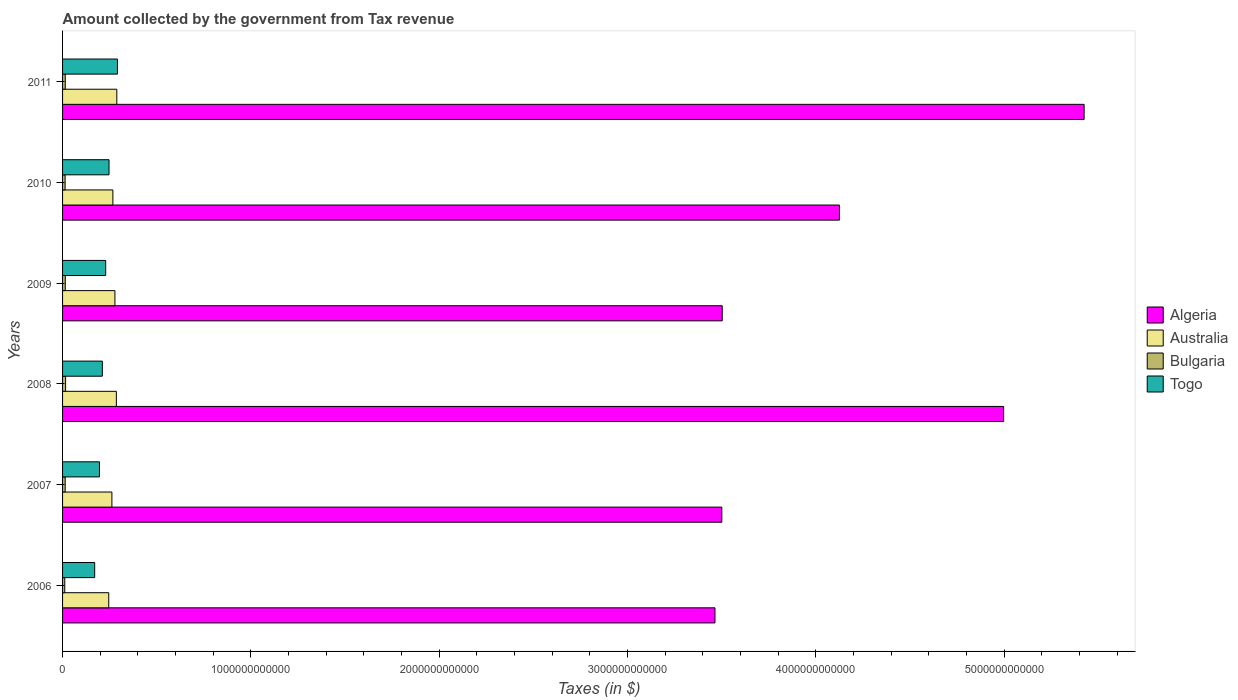How many different coloured bars are there?
Provide a short and direct response. 4. How many groups of bars are there?
Provide a succinct answer. 6. How many bars are there on the 4th tick from the top?
Keep it short and to the point. 4. How many bars are there on the 1st tick from the bottom?
Your answer should be compact. 4. What is the label of the 4th group of bars from the top?
Keep it short and to the point. 2008. What is the amount collected by the government from tax revenue in Bulgaria in 2008?
Offer a very short reply. 1.61e+1. Across all years, what is the maximum amount collected by the government from tax revenue in Togo?
Give a very brief answer. 2.91e+11. Across all years, what is the minimum amount collected by the government from tax revenue in Togo?
Give a very brief answer. 1.71e+11. In which year was the amount collected by the government from tax revenue in Togo maximum?
Provide a succinct answer. 2011. What is the total amount collected by the government from tax revenue in Togo in the graph?
Provide a succinct answer. 1.34e+12. What is the difference between the amount collected by the government from tax revenue in Australia in 2007 and that in 2010?
Your answer should be compact. -5.18e+09. What is the difference between the amount collected by the government from tax revenue in Algeria in 2010 and the amount collected by the government from tax revenue in Australia in 2007?
Make the answer very short. 3.86e+12. What is the average amount collected by the government from tax revenue in Algeria per year?
Offer a terse response. 4.17e+12. In the year 2010, what is the difference between the amount collected by the government from tax revenue in Bulgaria and amount collected by the government from tax revenue in Algeria?
Offer a terse response. -4.11e+12. In how many years, is the amount collected by the government from tax revenue in Togo greater than 1400000000000 $?
Offer a terse response. 0. What is the ratio of the amount collected by the government from tax revenue in Australia in 2008 to that in 2010?
Provide a short and direct response. 1.07. What is the difference between the highest and the second highest amount collected by the government from tax revenue in Togo?
Your response must be concise. 4.47e+1. What is the difference between the highest and the lowest amount collected by the government from tax revenue in Australia?
Offer a terse response. 4.28e+1. In how many years, is the amount collected by the government from tax revenue in Togo greater than the average amount collected by the government from tax revenue in Togo taken over all years?
Offer a terse response. 3. Is the sum of the amount collected by the government from tax revenue in Bulgaria in 2007 and 2008 greater than the maximum amount collected by the government from tax revenue in Togo across all years?
Keep it short and to the point. No. Is it the case that in every year, the sum of the amount collected by the government from tax revenue in Togo and amount collected by the government from tax revenue in Australia is greater than the sum of amount collected by the government from tax revenue in Bulgaria and amount collected by the government from tax revenue in Algeria?
Make the answer very short. No. Is it the case that in every year, the sum of the amount collected by the government from tax revenue in Algeria and amount collected by the government from tax revenue in Australia is greater than the amount collected by the government from tax revenue in Togo?
Your response must be concise. Yes. Are all the bars in the graph horizontal?
Provide a succinct answer. Yes. What is the difference between two consecutive major ticks on the X-axis?
Give a very brief answer. 1.00e+12. What is the title of the graph?
Provide a succinct answer. Amount collected by the government from Tax revenue. Does "Portugal" appear as one of the legend labels in the graph?
Your answer should be very brief. No. What is the label or title of the X-axis?
Your answer should be very brief. Taxes (in $). What is the Taxes (in $) of Algeria in 2006?
Offer a terse response. 3.46e+12. What is the Taxes (in $) in Australia in 2006?
Make the answer very short. 2.45e+11. What is the Taxes (in $) of Bulgaria in 2006?
Provide a short and direct response. 1.17e+1. What is the Taxes (in $) in Togo in 2006?
Offer a very short reply. 1.71e+11. What is the Taxes (in $) of Algeria in 2007?
Your answer should be very brief. 3.50e+12. What is the Taxes (in $) of Australia in 2007?
Offer a terse response. 2.62e+11. What is the Taxes (in $) in Bulgaria in 2007?
Your response must be concise. 1.39e+1. What is the Taxes (in $) in Togo in 2007?
Your answer should be very brief. 1.96e+11. What is the Taxes (in $) in Algeria in 2008?
Provide a succinct answer. 5.00e+12. What is the Taxes (in $) of Australia in 2008?
Your response must be concise. 2.86e+11. What is the Taxes (in $) in Bulgaria in 2008?
Your answer should be very brief. 1.61e+1. What is the Taxes (in $) of Togo in 2008?
Provide a succinct answer. 2.11e+11. What is the Taxes (in $) of Algeria in 2009?
Offer a terse response. 3.50e+12. What is the Taxes (in $) in Australia in 2009?
Give a very brief answer. 2.78e+11. What is the Taxes (in $) of Bulgaria in 2009?
Ensure brevity in your answer.  1.44e+1. What is the Taxes (in $) of Togo in 2009?
Make the answer very short. 2.29e+11. What is the Taxes (in $) of Algeria in 2010?
Make the answer very short. 4.13e+12. What is the Taxes (in $) of Australia in 2010?
Offer a very short reply. 2.67e+11. What is the Taxes (in $) in Bulgaria in 2010?
Keep it short and to the point. 1.35e+1. What is the Taxes (in $) in Togo in 2010?
Keep it short and to the point. 2.47e+11. What is the Taxes (in $) in Algeria in 2011?
Offer a very short reply. 5.42e+12. What is the Taxes (in $) in Australia in 2011?
Offer a very short reply. 2.88e+11. What is the Taxes (in $) in Bulgaria in 2011?
Make the answer very short. 1.43e+1. What is the Taxes (in $) of Togo in 2011?
Give a very brief answer. 2.91e+11. Across all years, what is the maximum Taxes (in $) of Algeria?
Your answer should be very brief. 5.42e+12. Across all years, what is the maximum Taxes (in $) of Australia?
Offer a terse response. 2.88e+11. Across all years, what is the maximum Taxes (in $) of Bulgaria?
Offer a terse response. 1.61e+1. Across all years, what is the maximum Taxes (in $) of Togo?
Your response must be concise. 2.91e+11. Across all years, what is the minimum Taxes (in $) in Algeria?
Provide a succinct answer. 3.46e+12. Across all years, what is the minimum Taxes (in $) in Australia?
Your answer should be compact. 2.45e+11. Across all years, what is the minimum Taxes (in $) of Bulgaria?
Give a very brief answer. 1.17e+1. Across all years, what is the minimum Taxes (in $) of Togo?
Keep it short and to the point. 1.71e+11. What is the total Taxes (in $) in Algeria in the graph?
Make the answer very short. 2.50e+13. What is the total Taxes (in $) in Australia in the graph?
Provide a short and direct response. 1.63e+12. What is the total Taxes (in $) of Bulgaria in the graph?
Ensure brevity in your answer.  8.39e+1. What is the total Taxes (in $) in Togo in the graph?
Your response must be concise. 1.34e+12. What is the difference between the Taxes (in $) of Algeria in 2006 and that in 2007?
Provide a succinct answer. -3.64e+1. What is the difference between the Taxes (in $) in Australia in 2006 and that in 2007?
Ensure brevity in your answer.  -1.68e+1. What is the difference between the Taxes (in $) of Bulgaria in 2006 and that in 2007?
Offer a terse response. -2.27e+09. What is the difference between the Taxes (in $) in Togo in 2006 and that in 2007?
Your response must be concise. -2.53e+1. What is the difference between the Taxes (in $) of Algeria in 2006 and that in 2008?
Your answer should be very brief. -1.53e+12. What is the difference between the Taxes (in $) in Australia in 2006 and that in 2008?
Your response must be concise. -4.04e+1. What is the difference between the Taxes (in $) of Bulgaria in 2006 and that in 2008?
Ensure brevity in your answer.  -4.47e+09. What is the difference between the Taxes (in $) in Togo in 2006 and that in 2008?
Your answer should be very brief. -4.06e+1. What is the difference between the Taxes (in $) in Algeria in 2006 and that in 2009?
Give a very brief answer. -3.86e+1. What is the difference between the Taxes (in $) of Australia in 2006 and that in 2009?
Provide a succinct answer. -3.28e+1. What is the difference between the Taxes (in $) in Bulgaria in 2006 and that in 2009?
Provide a succinct answer. -2.71e+09. What is the difference between the Taxes (in $) in Togo in 2006 and that in 2009?
Give a very brief answer. -5.85e+1. What is the difference between the Taxes (in $) in Algeria in 2006 and that in 2010?
Ensure brevity in your answer.  -6.61e+11. What is the difference between the Taxes (in $) of Australia in 2006 and that in 2010?
Provide a succinct answer. -2.19e+1. What is the difference between the Taxes (in $) in Bulgaria in 2006 and that in 2010?
Provide a short and direct response. -1.85e+09. What is the difference between the Taxes (in $) of Togo in 2006 and that in 2010?
Ensure brevity in your answer.  -7.62e+1. What is the difference between the Taxes (in $) of Algeria in 2006 and that in 2011?
Your answer should be very brief. -1.96e+12. What is the difference between the Taxes (in $) of Australia in 2006 and that in 2011?
Provide a short and direct response. -4.28e+1. What is the difference between the Taxes (in $) of Bulgaria in 2006 and that in 2011?
Make the answer very short. -2.70e+09. What is the difference between the Taxes (in $) of Togo in 2006 and that in 2011?
Make the answer very short. -1.21e+11. What is the difference between the Taxes (in $) in Algeria in 2007 and that in 2008?
Ensure brevity in your answer.  -1.50e+12. What is the difference between the Taxes (in $) in Australia in 2007 and that in 2008?
Give a very brief answer. -2.37e+1. What is the difference between the Taxes (in $) of Bulgaria in 2007 and that in 2008?
Give a very brief answer. -2.20e+09. What is the difference between the Taxes (in $) in Togo in 2007 and that in 2008?
Keep it short and to the point. -1.53e+1. What is the difference between the Taxes (in $) in Algeria in 2007 and that in 2009?
Offer a very short reply. -2.17e+09. What is the difference between the Taxes (in $) in Australia in 2007 and that in 2009?
Provide a succinct answer. -1.60e+1. What is the difference between the Taxes (in $) of Bulgaria in 2007 and that in 2009?
Your answer should be compact. -4.37e+08. What is the difference between the Taxes (in $) in Togo in 2007 and that in 2009?
Offer a terse response. -3.32e+1. What is the difference between the Taxes (in $) in Algeria in 2007 and that in 2010?
Your answer should be compact. -6.25e+11. What is the difference between the Taxes (in $) in Australia in 2007 and that in 2010?
Offer a very short reply. -5.18e+09. What is the difference between the Taxes (in $) in Bulgaria in 2007 and that in 2010?
Give a very brief answer. 4.21e+08. What is the difference between the Taxes (in $) of Togo in 2007 and that in 2010?
Make the answer very short. -5.09e+1. What is the difference between the Taxes (in $) of Algeria in 2007 and that in 2011?
Make the answer very short. -1.92e+12. What is the difference between the Taxes (in $) of Australia in 2007 and that in 2011?
Provide a succinct answer. -2.61e+1. What is the difference between the Taxes (in $) of Bulgaria in 2007 and that in 2011?
Your response must be concise. -4.28e+08. What is the difference between the Taxes (in $) in Togo in 2007 and that in 2011?
Provide a succinct answer. -9.56e+1. What is the difference between the Taxes (in $) of Algeria in 2008 and that in 2009?
Provide a succinct answer. 1.49e+12. What is the difference between the Taxes (in $) in Australia in 2008 and that in 2009?
Keep it short and to the point. 7.66e+09. What is the difference between the Taxes (in $) of Bulgaria in 2008 and that in 2009?
Keep it short and to the point. 1.77e+09. What is the difference between the Taxes (in $) of Togo in 2008 and that in 2009?
Give a very brief answer. -1.79e+1. What is the difference between the Taxes (in $) of Algeria in 2008 and that in 2010?
Offer a terse response. 8.72e+11. What is the difference between the Taxes (in $) in Australia in 2008 and that in 2010?
Offer a very short reply. 1.85e+1. What is the difference between the Taxes (in $) of Bulgaria in 2008 and that in 2010?
Provide a short and direct response. 2.62e+09. What is the difference between the Taxes (in $) in Togo in 2008 and that in 2010?
Give a very brief answer. -3.56e+1. What is the difference between the Taxes (in $) in Algeria in 2008 and that in 2011?
Your answer should be compact. -4.27e+11. What is the difference between the Taxes (in $) of Australia in 2008 and that in 2011?
Offer a very short reply. -2.41e+09. What is the difference between the Taxes (in $) in Bulgaria in 2008 and that in 2011?
Your answer should be very brief. 1.78e+09. What is the difference between the Taxes (in $) of Togo in 2008 and that in 2011?
Ensure brevity in your answer.  -8.02e+1. What is the difference between the Taxes (in $) in Algeria in 2009 and that in 2010?
Provide a succinct answer. -6.22e+11. What is the difference between the Taxes (in $) of Australia in 2009 and that in 2010?
Offer a terse response. 1.08e+1. What is the difference between the Taxes (in $) in Bulgaria in 2009 and that in 2010?
Keep it short and to the point. 8.58e+08. What is the difference between the Taxes (in $) in Togo in 2009 and that in 2010?
Your answer should be compact. -1.77e+1. What is the difference between the Taxes (in $) in Algeria in 2009 and that in 2011?
Offer a very short reply. -1.92e+12. What is the difference between the Taxes (in $) in Australia in 2009 and that in 2011?
Offer a terse response. -1.01e+1. What is the difference between the Taxes (in $) of Bulgaria in 2009 and that in 2011?
Keep it short and to the point. 9.09e+06. What is the difference between the Taxes (in $) in Togo in 2009 and that in 2011?
Your answer should be very brief. -6.24e+1. What is the difference between the Taxes (in $) in Algeria in 2010 and that in 2011?
Your answer should be very brief. -1.30e+12. What is the difference between the Taxes (in $) of Australia in 2010 and that in 2011?
Provide a short and direct response. -2.09e+1. What is the difference between the Taxes (in $) of Bulgaria in 2010 and that in 2011?
Provide a succinct answer. -8.49e+08. What is the difference between the Taxes (in $) of Togo in 2010 and that in 2011?
Your answer should be compact. -4.47e+1. What is the difference between the Taxes (in $) in Algeria in 2006 and the Taxes (in $) in Australia in 2007?
Give a very brief answer. 3.20e+12. What is the difference between the Taxes (in $) of Algeria in 2006 and the Taxes (in $) of Bulgaria in 2007?
Give a very brief answer. 3.45e+12. What is the difference between the Taxes (in $) of Algeria in 2006 and the Taxes (in $) of Togo in 2007?
Make the answer very short. 3.27e+12. What is the difference between the Taxes (in $) of Australia in 2006 and the Taxes (in $) of Bulgaria in 2007?
Provide a short and direct response. 2.31e+11. What is the difference between the Taxes (in $) in Australia in 2006 and the Taxes (in $) in Togo in 2007?
Provide a short and direct response. 4.94e+1. What is the difference between the Taxes (in $) in Bulgaria in 2006 and the Taxes (in $) in Togo in 2007?
Your answer should be compact. -1.84e+11. What is the difference between the Taxes (in $) of Algeria in 2006 and the Taxes (in $) of Australia in 2008?
Provide a succinct answer. 3.18e+12. What is the difference between the Taxes (in $) in Algeria in 2006 and the Taxes (in $) in Bulgaria in 2008?
Provide a succinct answer. 3.45e+12. What is the difference between the Taxes (in $) of Algeria in 2006 and the Taxes (in $) of Togo in 2008?
Your response must be concise. 3.25e+12. What is the difference between the Taxes (in $) of Australia in 2006 and the Taxes (in $) of Bulgaria in 2008?
Make the answer very short. 2.29e+11. What is the difference between the Taxes (in $) of Australia in 2006 and the Taxes (in $) of Togo in 2008?
Your answer should be very brief. 3.40e+1. What is the difference between the Taxes (in $) of Bulgaria in 2006 and the Taxes (in $) of Togo in 2008?
Provide a succinct answer. -2.00e+11. What is the difference between the Taxes (in $) in Algeria in 2006 and the Taxes (in $) in Australia in 2009?
Make the answer very short. 3.19e+12. What is the difference between the Taxes (in $) of Algeria in 2006 and the Taxes (in $) of Bulgaria in 2009?
Your answer should be very brief. 3.45e+12. What is the difference between the Taxes (in $) in Algeria in 2006 and the Taxes (in $) in Togo in 2009?
Provide a succinct answer. 3.24e+12. What is the difference between the Taxes (in $) of Australia in 2006 and the Taxes (in $) of Bulgaria in 2009?
Offer a very short reply. 2.31e+11. What is the difference between the Taxes (in $) of Australia in 2006 and the Taxes (in $) of Togo in 2009?
Your answer should be compact. 1.61e+1. What is the difference between the Taxes (in $) of Bulgaria in 2006 and the Taxes (in $) of Togo in 2009?
Make the answer very short. -2.17e+11. What is the difference between the Taxes (in $) of Algeria in 2006 and the Taxes (in $) of Australia in 2010?
Your answer should be very brief. 3.20e+12. What is the difference between the Taxes (in $) in Algeria in 2006 and the Taxes (in $) in Bulgaria in 2010?
Offer a terse response. 3.45e+12. What is the difference between the Taxes (in $) in Algeria in 2006 and the Taxes (in $) in Togo in 2010?
Your answer should be very brief. 3.22e+12. What is the difference between the Taxes (in $) in Australia in 2006 and the Taxes (in $) in Bulgaria in 2010?
Give a very brief answer. 2.32e+11. What is the difference between the Taxes (in $) of Australia in 2006 and the Taxes (in $) of Togo in 2010?
Your answer should be very brief. -1.56e+09. What is the difference between the Taxes (in $) in Bulgaria in 2006 and the Taxes (in $) in Togo in 2010?
Provide a succinct answer. -2.35e+11. What is the difference between the Taxes (in $) of Algeria in 2006 and the Taxes (in $) of Australia in 2011?
Keep it short and to the point. 3.18e+12. What is the difference between the Taxes (in $) in Algeria in 2006 and the Taxes (in $) in Bulgaria in 2011?
Your answer should be very brief. 3.45e+12. What is the difference between the Taxes (in $) of Algeria in 2006 and the Taxes (in $) of Togo in 2011?
Give a very brief answer. 3.17e+12. What is the difference between the Taxes (in $) in Australia in 2006 and the Taxes (in $) in Bulgaria in 2011?
Your answer should be very brief. 2.31e+11. What is the difference between the Taxes (in $) in Australia in 2006 and the Taxes (in $) in Togo in 2011?
Your response must be concise. -4.62e+1. What is the difference between the Taxes (in $) in Bulgaria in 2006 and the Taxes (in $) in Togo in 2011?
Ensure brevity in your answer.  -2.80e+11. What is the difference between the Taxes (in $) of Algeria in 2007 and the Taxes (in $) of Australia in 2008?
Your answer should be very brief. 3.22e+12. What is the difference between the Taxes (in $) of Algeria in 2007 and the Taxes (in $) of Bulgaria in 2008?
Ensure brevity in your answer.  3.48e+12. What is the difference between the Taxes (in $) in Algeria in 2007 and the Taxes (in $) in Togo in 2008?
Ensure brevity in your answer.  3.29e+12. What is the difference between the Taxes (in $) of Australia in 2007 and the Taxes (in $) of Bulgaria in 2008?
Your response must be concise. 2.46e+11. What is the difference between the Taxes (in $) of Australia in 2007 and the Taxes (in $) of Togo in 2008?
Offer a very short reply. 5.08e+1. What is the difference between the Taxes (in $) of Bulgaria in 2007 and the Taxes (in $) of Togo in 2008?
Ensure brevity in your answer.  -1.97e+11. What is the difference between the Taxes (in $) in Algeria in 2007 and the Taxes (in $) in Australia in 2009?
Provide a short and direct response. 3.22e+12. What is the difference between the Taxes (in $) in Algeria in 2007 and the Taxes (in $) in Bulgaria in 2009?
Offer a very short reply. 3.49e+12. What is the difference between the Taxes (in $) of Algeria in 2007 and the Taxes (in $) of Togo in 2009?
Provide a short and direct response. 3.27e+12. What is the difference between the Taxes (in $) in Australia in 2007 and the Taxes (in $) in Bulgaria in 2009?
Ensure brevity in your answer.  2.48e+11. What is the difference between the Taxes (in $) of Australia in 2007 and the Taxes (in $) of Togo in 2009?
Your answer should be compact. 3.29e+1. What is the difference between the Taxes (in $) in Bulgaria in 2007 and the Taxes (in $) in Togo in 2009?
Your answer should be compact. -2.15e+11. What is the difference between the Taxes (in $) of Algeria in 2007 and the Taxes (in $) of Australia in 2010?
Offer a very short reply. 3.23e+12. What is the difference between the Taxes (in $) of Algeria in 2007 and the Taxes (in $) of Bulgaria in 2010?
Ensure brevity in your answer.  3.49e+12. What is the difference between the Taxes (in $) in Algeria in 2007 and the Taxes (in $) in Togo in 2010?
Offer a terse response. 3.25e+12. What is the difference between the Taxes (in $) of Australia in 2007 and the Taxes (in $) of Bulgaria in 2010?
Make the answer very short. 2.48e+11. What is the difference between the Taxes (in $) of Australia in 2007 and the Taxes (in $) of Togo in 2010?
Your answer should be compact. 1.52e+1. What is the difference between the Taxes (in $) of Bulgaria in 2007 and the Taxes (in $) of Togo in 2010?
Offer a very short reply. -2.33e+11. What is the difference between the Taxes (in $) of Algeria in 2007 and the Taxes (in $) of Australia in 2011?
Give a very brief answer. 3.21e+12. What is the difference between the Taxes (in $) in Algeria in 2007 and the Taxes (in $) in Bulgaria in 2011?
Keep it short and to the point. 3.49e+12. What is the difference between the Taxes (in $) of Algeria in 2007 and the Taxes (in $) of Togo in 2011?
Your answer should be compact. 3.21e+12. What is the difference between the Taxes (in $) of Australia in 2007 and the Taxes (in $) of Bulgaria in 2011?
Your answer should be compact. 2.48e+11. What is the difference between the Taxes (in $) of Australia in 2007 and the Taxes (in $) of Togo in 2011?
Offer a terse response. -2.95e+1. What is the difference between the Taxes (in $) of Bulgaria in 2007 and the Taxes (in $) of Togo in 2011?
Provide a short and direct response. -2.78e+11. What is the difference between the Taxes (in $) of Algeria in 2008 and the Taxes (in $) of Australia in 2009?
Ensure brevity in your answer.  4.72e+12. What is the difference between the Taxes (in $) in Algeria in 2008 and the Taxes (in $) in Bulgaria in 2009?
Your answer should be very brief. 4.98e+12. What is the difference between the Taxes (in $) in Algeria in 2008 and the Taxes (in $) in Togo in 2009?
Your answer should be compact. 4.77e+12. What is the difference between the Taxes (in $) in Australia in 2008 and the Taxes (in $) in Bulgaria in 2009?
Your response must be concise. 2.71e+11. What is the difference between the Taxes (in $) in Australia in 2008 and the Taxes (in $) in Togo in 2009?
Make the answer very short. 5.66e+1. What is the difference between the Taxes (in $) of Bulgaria in 2008 and the Taxes (in $) of Togo in 2009?
Keep it short and to the point. -2.13e+11. What is the difference between the Taxes (in $) in Algeria in 2008 and the Taxes (in $) in Australia in 2010?
Ensure brevity in your answer.  4.73e+12. What is the difference between the Taxes (in $) in Algeria in 2008 and the Taxes (in $) in Bulgaria in 2010?
Offer a terse response. 4.98e+12. What is the difference between the Taxes (in $) in Algeria in 2008 and the Taxes (in $) in Togo in 2010?
Your answer should be very brief. 4.75e+12. What is the difference between the Taxes (in $) of Australia in 2008 and the Taxes (in $) of Bulgaria in 2010?
Offer a terse response. 2.72e+11. What is the difference between the Taxes (in $) of Australia in 2008 and the Taxes (in $) of Togo in 2010?
Offer a very short reply. 3.89e+1. What is the difference between the Taxes (in $) in Bulgaria in 2008 and the Taxes (in $) in Togo in 2010?
Make the answer very short. -2.31e+11. What is the difference between the Taxes (in $) in Algeria in 2008 and the Taxes (in $) in Australia in 2011?
Your answer should be very brief. 4.71e+12. What is the difference between the Taxes (in $) of Algeria in 2008 and the Taxes (in $) of Bulgaria in 2011?
Give a very brief answer. 4.98e+12. What is the difference between the Taxes (in $) of Algeria in 2008 and the Taxes (in $) of Togo in 2011?
Ensure brevity in your answer.  4.71e+12. What is the difference between the Taxes (in $) in Australia in 2008 and the Taxes (in $) in Bulgaria in 2011?
Your answer should be very brief. 2.71e+11. What is the difference between the Taxes (in $) in Australia in 2008 and the Taxes (in $) in Togo in 2011?
Make the answer very short. -5.78e+09. What is the difference between the Taxes (in $) of Bulgaria in 2008 and the Taxes (in $) of Togo in 2011?
Your answer should be compact. -2.75e+11. What is the difference between the Taxes (in $) in Algeria in 2009 and the Taxes (in $) in Australia in 2010?
Offer a terse response. 3.24e+12. What is the difference between the Taxes (in $) in Algeria in 2009 and the Taxes (in $) in Bulgaria in 2010?
Offer a terse response. 3.49e+12. What is the difference between the Taxes (in $) of Algeria in 2009 and the Taxes (in $) of Togo in 2010?
Your answer should be very brief. 3.26e+12. What is the difference between the Taxes (in $) of Australia in 2009 and the Taxes (in $) of Bulgaria in 2010?
Your answer should be very brief. 2.64e+11. What is the difference between the Taxes (in $) of Australia in 2009 and the Taxes (in $) of Togo in 2010?
Give a very brief answer. 3.12e+1. What is the difference between the Taxes (in $) of Bulgaria in 2009 and the Taxes (in $) of Togo in 2010?
Make the answer very short. -2.32e+11. What is the difference between the Taxes (in $) in Algeria in 2009 and the Taxes (in $) in Australia in 2011?
Offer a very short reply. 3.21e+12. What is the difference between the Taxes (in $) of Algeria in 2009 and the Taxes (in $) of Bulgaria in 2011?
Your answer should be compact. 3.49e+12. What is the difference between the Taxes (in $) in Algeria in 2009 and the Taxes (in $) in Togo in 2011?
Provide a short and direct response. 3.21e+12. What is the difference between the Taxes (in $) in Australia in 2009 and the Taxes (in $) in Bulgaria in 2011?
Your answer should be compact. 2.64e+11. What is the difference between the Taxes (in $) in Australia in 2009 and the Taxes (in $) in Togo in 2011?
Ensure brevity in your answer.  -1.34e+1. What is the difference between the Taxes (in $) in Bulgaria in 2009 and the Taxes (in $) in Togo in 2011?
Your answer should be very brief. -2.77e+11. What is the difference between the Taxes (in $) of Algeria in 2010 and the Taxes (in $) of Australia in 2011?
Keep it short and to the point. 3.84e+12. What is the difference between the Taxes (in $) of Algeria in 2010 and the Taxes (in $) of Bulgaria in 2011?
Keep it short and to the point. 4.11e+12. What is the difference between the Taxes (in $) in Algeria in 2010 and the Taxes (in $) in Togo in 2011?
Give a very brief answer. 3.83e+12. What is the difference between the Taxes (in $) of Australia in 2010 and the Taxes (in $) of Bulgaria in 2011?
Make the answer very short. 2.53e+11. What is the difference between the Taxes (in $) in Australia in 2010 and the Taxes (in $) in Togo in 2011?
Your answer should be very brief. -2.43e+1. What is the difference between the Taxes (in $) in Bulgaria in 2010 and the Taxes (in $) in Togo in 2011?
Provide a short and direct response. -2.78e+11. What is the average Taxes (in $) in Algeria per year?
Ensure brevity in your answer.  4.17e+12. What is the average Taxes (in $) of Australia per year?
Offer a terse response. 2.71e+11. What is the average Taxes (in $) of Bulgaria per year?
Provide a short and direct response. 1.40e+1. What is the average Taxes (in $) in Togo per year?
Ensure brevity in your answer.  2.24e+11. In the year 2006, what is the difference between the Taxes (in $) of Algeria and Taxes (in $) of Australia?
Keep it short and to the point. 3.22e+12. In the year 2006, what is the difference between the Taxes (in $) in Algeria and Taxes (in $) in Bulgaria?
Ensure brevity in your answer.  3.45e+12. In the year 2006, what is the difference between the Taxes (in $) in Algeria and Taxes (in $) in Togo?
Make the answer very short. 3.29e+12. In the year 2006, what is the difference between the Taxes (in $) of Australia and Taxes (in $) of Bulgaria?
Offer a terse response. 2.34e+11. In the year 2006, what is the difference between the Taxes (in $) of Australia and Taxes (in $) of Togo?
Provide a short and direct response. 7.46e+1. In the year 2006, what is the difference between the Taxes (in $) of Bulgaria and Taxes (in $) of Togo?
Give a very brief answer. -1.59e+11. In the year 2007, what is the difference between the Taxes (in $) of Algeria and Taxes (in $) of Australia?
Make the answer very short. 3.24e+12. In the year 2007, what is the difference between the Taxes (in $) in Algeria and Taxes (in $) in Bulgaria?
Provide a succinct answer. 3.49e+12. In the year 2007, what is the difference between the Taxes (in $) in Algeria and Taxes (in $) in Togo?
Ensure brevity in your answer.  3.31e+12. In the year 2007, what is the difference between the Taxes (in $) of Australia and Taxes (in $) of Bulgaria?
Provide a short and direct response. 2.48e+11. In the year 2007, what is the difference between the Taxes (in $) of Australia and Taxes (in $) of Togo?
Provide a short and direct response. 6.61e+1. In the year 2007, what is the difference between the Taxes (in $) in Bulgaria and Taxes (in $) in Togo?
Your answer should be compact. -1.82e+11. In the year 2008, what is the difference between the Taxes (in $) of Algeria and Taxes (in $) of Australia?
Your answer should be compact. 4.71e+12. In the year 2008, what is the difference between the Taxes (in $) in Algeria and Taxes (in $) in Bulgaria?
Your answer should be very brief. 4.98e+12. In the year 2008, what is the difference between the Taxes (in $) of Algeria and Taxes (in $) of Togo?
Ensure brevity in your answer.  4.79e+12. In the year 2008, what is the difference between the Taxes (in $) of Australia and Taxes (in $) of Bulgaria?
Ensure brevity in your answer.  2.70e+11. In the year 2008, what is the difference between the Taxes (in $) of Australia and Taxes (in $) of Togo?
Provide a succinct answer. 7.45e+1. In the year 2008, what is the difference between the Taxes (in $) in Bulgaria and Taxes (in $) in Togo?
Your answer should be compact. -1.95e+11. In the year 2009, what is the difference between the Taxes (in $) in Algeria and Taxes (in $) in Australia?
Ensure brevity in your answer.  3.23e+12. In the year 2009, what is the difference between the Taxes (in $) of Algeria and Taxes (in $) of Bulgaria?
Ensure brevity in your answer.  3.49e+12. In the year 2009, what is the difference between the Taxes (in $) of Algeria and Taxes (in $) of Togo?
Make the answer very short. 3.27e+12. In the year 2009, what is the difference between the Taxes (in $) in Australia and Taxes (in $) in Bulgaria?
Keep it short and to the point. 2.64e+11. In the year 2009, what is the difference between the Taxes (in $) in Australia and Taxes (in $) in Togo?
Give a very brief answer. 4.89e+1. In the year 2009, what is the difference between the Taxes (in $) of Bulgaria and Taxes (in $) of Togo?
Make the answer very short. -2.15e+11. In the year 2010, what is the difference between the Taxes (in $) in Algeria and Taxes (in $) in Australia?
Your response must be concise. 3.86e+12. In the year 2010, what is the difference between the Taxes (in $) in Algeria and Taxes (in $) in Bulgaria?
Give a very brief answer. 4.11e+12. In the year 2010, what is the difference between the Taxes (in $) in Algeria and Taxes (in $) in Togo?
Your response must be concise. 3.88e+12. In the year 2010, what is the difference between the Taxes (in $) in Australia and Taxes (in $) in Bulgaria?
Your response must be concise. 2.54e+11. In the year 2010, what is the difference between the Taxes (in $) in Australia and Taxes (in $) in Togo?
Offer a very short reply. 2.04e+1. In the year 2010, what is the difference between the Taxes (in $) in Bulgaria and Taxes (in $) in Togo?
Offer a terse response. -2.33e+11. In the year 2011, what is the difference between the Taxes (in $) of Algeria and Taxes (in $) of Australia?
Provide a short and direct response. 5.14e+12. In the year 2011, what is the difference between the Taxes (in $) in Algeria and Taxes (in $) in Bulgaria?
Offer a very short reply. 5.41e+12. In the year 2011, what is the difference between the Taxes (in $) of Algeria and Taxes (in $) of Togo?
Your response must be concise. 5.13e+12. In the year 2011, what is the difference between the Taxes (in $) in Australia and Taxes (in $) in Bulgaria?
Ensure brevity in your answer.  2.74e+11. In the year 2011, what is the difference between the Taxes (in $) in Australia and Taxes (in $) in Togo?
Your response must be concise. -3.37e+09. In the year 2011, what is the difference between the Taxes (in $) of Bulgaria and Taxes (in $) of Togo?
Give a very brief answer. -2.77e+11. What is the ratio of the Taxes (in $) in Australia in 2006 to that in 2007?
Give a very brief answer. 0.94. What is the ratio of the Taxes (in $) of Bulgaria in 2006 to that in 2007?
Make the answer very short. 0.84. What is the ratio of the Taxes (in $) of Togo in 2006 to that in 2007?
Your response must be concise. 0.87. What is the ratio of the Taxes (in $) of Algeria in 2006 to that in 2008?
Offer a terse response. 0.69. What is the ratio of the Taxes (in $) in Australia in 2006 to that in 2008?
Make the answer very short. 0.86. What is the ratio of the Taxes (in $) of Bulgaria in 2006 to that in 2008?
Your response must be concise. 0.72. What is the ratio of the Taxes (in $) of Togo in 2006 to that in 2008?
Offer a terse response. 0.81. What is the ratio of the Taxes (in $) of Algeria in 2006 to that in 2009?
Ensure brevity in your answer.  0.99. What is the ratio of the Taxes (in $) in Australia in 2006 to that in 2009?
Ensure brevity in your answer.  0.88. What is the ratio of the Taxes (in $) in Bulgaria in 2006 to that in 2009?
Give a very brief answer. 0.81. What is the ratio of the Taxes (in $) in Togo in 2006 to that in 2009?
Offer a very short reply. 0.74. What is the ratio of the Taxes (in $) in Algeria in 2006 to that in 2010?
Offer a very short reply. 0.84. What is the ratio of the Taxes (in $) in Australia in 2006 to that in 2010?
Offer a terse response. 0.92. What is the ratio of the Taxes (in $) in Bulgaria in 2006 to that in 2010?
Your response must be concise. 0.86. What is the ratio of the Taxes (in $) of Togo in 2006 to that in 2010?
Make the answer very short. 0.69. What is the ratio of the Taxes (in $) of Algeria in 2006 to that in 2011?
Give a very brief answer. 0.64. What is the ratio of the Taxes (in $) of Australia in 2006 to that in 2011?
Provide a short and direct response. 0.85. What is the ratio of the Taxes (in $) in Bulgaria in 2006 to that in 2011?
Give a very brief answer. 0.81. What is the ratio of the Taxes (in $) in Togo in 2006 to that in 2011?
Offer a very short reply. 0.59. What is the ratio of the Taxes (in $) of Algeria in 2007 to that in 2008?
Provide a succinct answer. 0.7. What is the ratio of the Taxes (in $) of Australia in 2007 to that in 2008?
Provide a short and direct response. 0.92. What is the ratio of the Taxes (in $) of Bulgaria in 2007 to that in 2008?
Your answer should be very brief. 0.86. What is the ratio of the Taxes (in $) of Togo in 2007 to that in 2008?
Offer a very short reply. 0.93. What is the ratio of the Taxes (in $) in Australia in 2007 to that in 2009?
Keep it short and to the point. 0.94. What is the ratio of the Taxes (in $) in Bulgaria in 2007 to that in 2009?
Provide a succinct answer. 0.97. What is the ratio of the Taxes (in $) in Togo in 2007 to that in 2009?
Offer a very short reply. 0.85. What is the ratio of the Taxes (in $) of Algeria in 2007 to that in 2010?
Your response must be concise. 0.85. What is the ratio of the Taxes (in $) in Australia in 2007 to that in 2010?
Give a very brief answer. 0.98. What is the ratio of the Taxes (in $) of Bulgaria in 2007 to that in 2010?
Make the answer very short. 1.03. What is the ratio of the Taxes (in $) in Togo in 2007 to that in 2010?
Your answer should be very brief. 0.79. What is the ratio of the Taxes (in $) of Algeria in 2007 to that in 2011?
Make the answer very short. 0.65. What is the ratio of the Taxes (in $) in Australia in 2007 to that in 2011?
Your answer should be very brief. 0.91. What is the ratio of the Taxes (in $) of Bulgaria in 2007 to that in 2011?
Provide a succinct answer. 0.97. What is the ratio of the Taxes (in $) in Togo in 2007 to that in 2011?
Offer a very short reply. 0.67. What is the ratio of the Taxes (in $) in Algeria in 2008 to that in 2009?
Your answer should be very brief. 1.43. What is the ratio of the Taxes (in $) in Australia in 2008 to that in 2009?
Your answer should be very brief. 1.03. What is the ratio of the Taxes (in $) in Bulgaria in 2008 to that in 2009?
Your answer should be very brief. 1.12. What is the ratio of the Taxes (in $) of Togo in 2008 to that in 2009?
Ensure brevity in your answer.  0.92. What is the ratio of the Taxes (in $) in Algeria in 2008 to that in 2010?
Your response must be concise. 1.21. What is the ratio of the Taxes (in $) of Australia in 2008 to that in 2010?
Ensure brevity in your answer.  1.07. What is the ratio of the Taxes (in $) in Bulgaria in 2008 to that in 2010?
Offer a terse response. 1.19. What is the ratio of the Taxes (in $) of Togo in 2008 to that in 2010?
Offer a very short reply. 0.86. What is the ratio of the Taxes (in $) in Algeria in 2008 to that in 2011?
Your response must be concise. 0.92. What is the ratio of the Taxes (in $) of Bulgaria in 2008 to that in 2011?
Offer a terse response. 1.12. What is the ratio of the Taxes (in $) of Togo in 2008 to that in 2011?
Provide a succinct answer. 0.72. What is the ratio of the Taxes (in $) of Algeria in 2009 to that in 2010?
Your answer should be very brief. 0.85. What is the ratio of the Taxes (in $) in Australia in 2009 to that in 2010?
Provide a succinct answer. 1.04. What is the ratio of the Taxes (in $) of Bulgaria in 2009 to that in 2010?
Offer a terse response. 1.06. What is the ratio of the Taxes (in $) in Togo in 2009 to that in 2010?
Provide a short and direct response. 0.93. What is the ratio of the Taxes (in $) of Algeria in 2009 to that in 2011?
Your answer should be very brief. 0.65. What is the ratio of the Taxes (in $) in Australia in 2009 to that in 2011?
Keep it short and to the point. 0.97. What is the ratio of the Taxes (in $) in Bulgaria in 2009 to that in 2011?
Provide a succinct answer. 1. What is the ratio of the Taxes (in $) in Togo in 2009 to that in 2011?
Your response must be concise. 0.79. What is the ratio of the Taxes (in $) in Algeria in 2010 to that in 2011?
Your response must be concise. 0.76. What is the ratio of the Taxes (in $) in Australia in 2010 to that in 2011?
Ensure brevity in your answer.  0.93. What is the ratio of the Taxes (in $) in Bulgaria in 2010 to that in 2011?
Provide a succinct answer. 0.94. What is the ratio of the Taxes (in $) of Togo in 2010 to that in 2011?
Your response must be concise. 0.85. What is the difference between the highest and the second highest Taxes (in $) of Algeria?
Offer a terse response. 4.27e+11. What is the difference between the highest and the second highest Taxes (in $) of Australia?
Your answer should be compact. 2.41e+09. What is the difference between the highest and the second highest Taxes (in $) of Bulgaria?
Keep it short and to the point. 1.77e+09. What is the difference between the highest and the second highest Taxes (in $) of Togo?
Keep it short and to the point. 4.47e+1. What is the difference between the highest and the lowest Taxes (in $) of Algeria?
Ensure brevity in your answer.  1.96e+12. What is the difference between the highest and the lowest Taxes (in $) of Australia?
Offer a terse response. 4.28e+1. What is the difference between the highest and the lowest Taxes (in $) in Bulgaria?
Offer a terse response. 4.47e+09. What is the difference between the highest and the lowest Taxes (in $) of Togo?
Make the answer very short. 1.21e+11. 